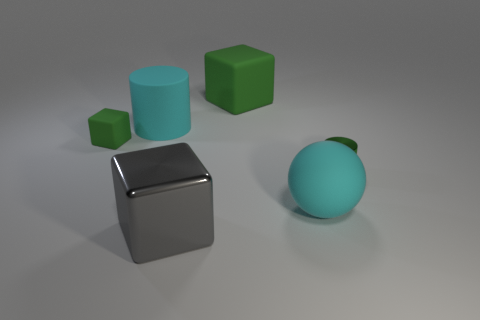What do you think is the function of the blue sphere? Given its simple geometric form and the context of the image being a still life of various shapes, the blue sphere likely serves no practical function beyond being an object for visual study. It might be used to understand the interplay of light and shadow on curved surfaces or to provide a color contrast in the composition. 